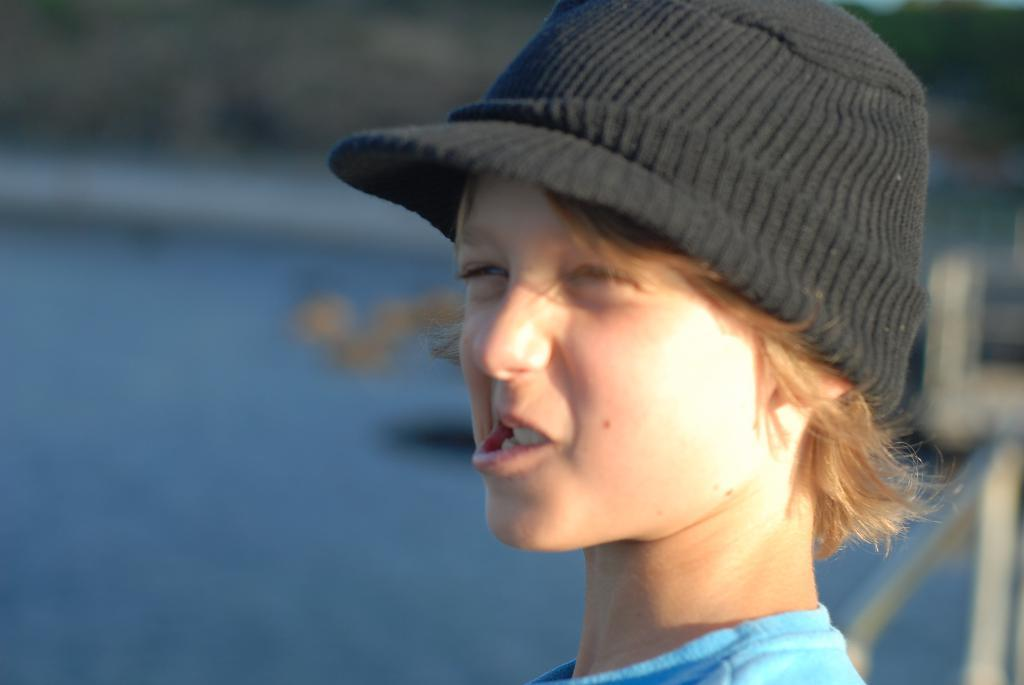What is the main subject of the image? There is a boy in the image. What is the boy doing in the image? The boy is standing and smiling. What can be seen in the background of the image? The background of the image is blurred. What type of bird can be seen flying in the image? There is no bird visible in the image; it only features a boy standing and smiling with a blurred background. 